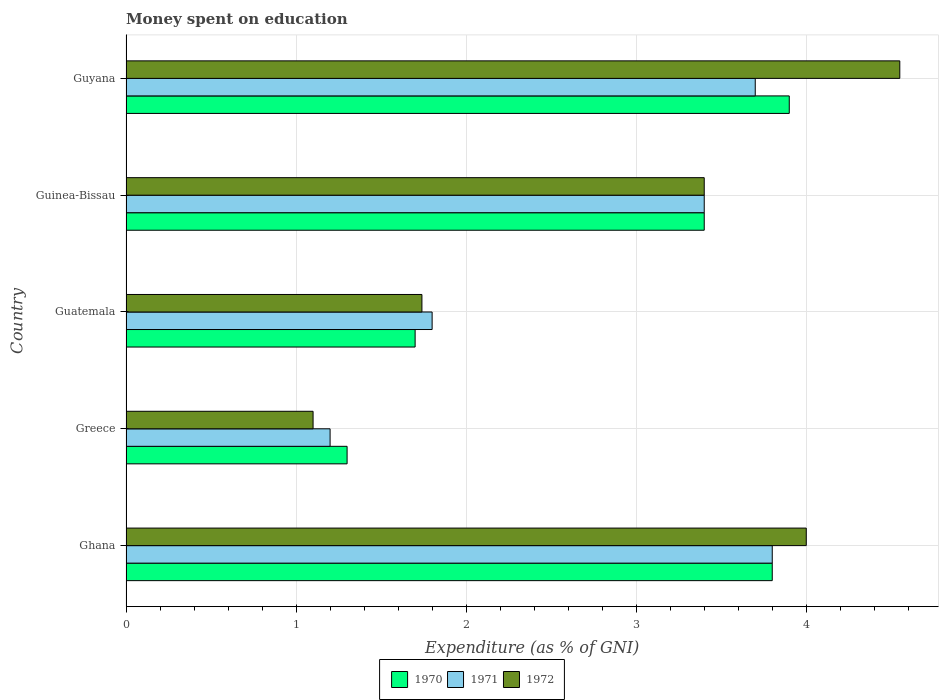How many different coloured bars are there?
Give a very brief answer. 3. How many groups of bars are there?
Offer a terse response. 5. Are the number of bars per tick equal to the number of legend labels?
Keep it short and to the point. Yes. Are the number of bars on each tick of the Y-axis equal?
Give a very brief answer. Yes. How many bars are there on the 1st tick from the bottom?
Make the answer very short. 3. What is the label of the 3rd group of bars from the top?
Give a very brief answer. Guatemala. In how many cases, is the number of bars for a given country not equal to the number of legend labels?
Offer a very short reply. 0. What is the amount of money spent on education in 1972 in Guatemala?
Ensure brevity in your answer.  1.74. Across all countries, what is the maximum amount of money spent on education in 1972?
Keep it short and to the point. 4.55. Across all countries, what is the minimum amount of money spent on education in 1970?
Ensure brevity in your answer.  1.3. In which country was the amount of money spent on education in 1970 maximum?
Ensure brevity in your answer.  Guyana. In which country was the amount of money spent on education in 1971 minimum?
Provide a short and direct response. Greece. What is the total amount of money spent on education in 1971 in the graph?
Provide a short and direct response. 13.9. What is the difference between the amount of money spent on education in 1971 in Greece and that in Guatemala?
Your answer should be very brief. -0.6. What is the difference between the amount of money spent on education in 1970 in Greece and the amount of money spent on education in 1971 in Guinea-Bissau?
Your answer should be compact. -2.1. What is the average amount of money spent on education in 1970 per country?
Your answer should be very brief. 2.82. What is the difference between the amount of money spent on education in 1972 and amount of money spent on education in 1971 in Guyana?
Keep it short and to the point. 0.85. In how many countries, is the amount of money spent on education in 1971 greater than 0.6000000000000001 %?
Make the answer very short. 5. What is the ratio of the amount of money spent on education in 1971 in Greece to that in Guatemala?
Keep it short and to the point. 0.67. Is the difference between the amount of money spent on education in 1972 in Ghana and Guinea-Bissau greater than the difference between the amount of money spent on education in 1971 in Ghana and Guinea-Bissau?
Ensure brevity in your answer.  Yes. What is the difference between the highest and the second highest amount of money spent on education in 1971?
Offer a terse response. 0.1. What is the difference between the highest and the lowest amount of money spent on education in 1970?
Your answer should be compact. 2.6. In how many countries, is the amount of money spent on education in 1971 greater than the average amount of money spent on education in 1971 taken over all countries?
Provide a succinct answer. 3. How many bars are there?
Your response must be concise. 15. Are all the bars in the graph horizontal?
Your answer should be very brief. Yes. Are the values on the major ticks of X-axis written in scientific E-notation?
Ensure brevity in your answer.  No. Does the graph contain any zero values?
Make the answer very short. No. Where does the legend appear in the graph?
Provide a succinct answer. Bottom center. How many legend labels are there?
Provide a short and direct response. 3. How are the legend labels stacked?
Your answer should be very brief. Horizontal. What is the title of the graph?
Your answer should be very brief. Money spent on education. What is the label or title of the X-axis?
Provide a short and direct response. Expenditure (as % of GNI). What is the label or title of the Y-axis?
Offer a terse response. Country. What is the Expenditure (as % of GNI) in 1971 in Ghana?
Keep it short and to the point. 3.8. What is the Expenditure (as % of GNI) of 1972 in Ghana?
Your answer should be compact. 4. What is the Expenditure (as % of GNI) of 1971 in Greece?
Ensure brevity in your answer.  1.2. What is the Expenditure (as % of GNI) of 1972 in Greece?
Provide a succinct answer. 1.1. What is the Expenditure (as % of GNI) in 1971 in Guatemala?
Provide a short and direct response. 1.8. What is the Expenditure (as % of GNI) in 1972 in Guatemala?
Your answer should be compact. 1.74. What is the Expenditure (as % of GNI) of 1970 in Guinea-Bissau?
Your response must be concise. 3.4. What is the Expenditure (as % of GNI) of 1972 in Guinea-Bissau?
Provide a short and direct response. 3.4. What is the Expenditure (as % of GNI) of 1970 in Guyana?
Offer a terse response. 3.9. What is the Expenditure (as % of GNI) in 1971 in Guyana?
Ensure brevity in your answer.  3.7. What is the Expenditure (as % of GNI) in 1972 in Guyana?
Give a very brief answer. 4.55. Across all countries, what is the maximum Expenditure (as % of GNI) in 1970?
Provide a succinct answer. 3.9. Across all countries, what is the maximum Expenditure (as % of GNI) of 1971?
Offer a very short reply. 3.8. Across all countries, what is the maximum Expenditure (as % of GNI) of 1972?
Offer a very short reply. 4.55. Across all countries, what is the minimum Expenditure (as % of GNI) in 1970?
Provide a succinct answer. 1.3. Across all countries, what is the minimum Expenditure (as % of GNI) in 1972?
Your answer should be very brief. 1.1. What is the total Expenditure (as % of GNI) of 1970 in the graph?
Provide a succinct answer. 14.1. What is the total Expenditure (as % of GNI) in 1971 in the graph?
Keep it short and to the point. 13.9. What is the total Expenditure (as % of GNI) of 1972 in the graph?
Provide a short and direct response. 14.79. What is the difference between the Expenditure (as % of GNI) in 1970 in Ghana and that in Greece?
Offer a terse response. 2.5. What is the difference between the Expenditure (as % of GNI) of 1972 in Ghana and that in Guatemala?
Your answer should be compact. 2.26. What is the difference between the Expenditure (as % of GNI) in 1970 in Ghana and that in Guinea-Bissau?
Offer a very short reply. 0.4. What is the difference between the Expenditure (as % of GNI) of 1972 in Ghana and that in Guinea-Bissau?
Offer a very short reply. 0.6. What is the difference between the Expenditure (as % of GNI) in 1972 in Ghana and that in Guyana?
Provide a succinct answer. -0.55. What is the difference between the Expenditure (as % of GNI) in 1972 in Greece and that in Guatemala?
Provide a succinct answer. -0.64. What is the difference between the Expenditure (as % of GNI) of 1972 in Greece and that in Guinea-Bissau?
Your answer should be compact. -2.3. What is the difference between the Expenditure (as % of GNI) of 1971 in Greece and that in Guyana?
Give a very brief answer. -2.5. What is the difference between the Expenditure (as % of GNI) of 1972 in Greece and that in Guyana?
Provide a short and direct response. -3.45. What is the difference between the Expenditure (as % of GNI) of 1971 in Guatemala and that in Guinea-Bissau?
Offer a very short reply. -1.6. What is the difference between the Expenditure (as % of GNI) in 1972 in Guatemala and that in Guinea-Bissau?
Your response must be concise. -1.66. What is the difference between the Expenditure (as % of GNI) in 1970 in Guatemala and that in Guyana?
Provide a short and direct response. -2.2. What is the difference between the Expenditure (as % of GNI) of 1972 in Guatemala and that in Guyana?
Give a very brief answer. -2.81. What is the difference between the Expenditure (as % of GNI) of 1970 in Guinea-Bissau and that in Guyana?
Make the answer very short. -0.5. What is the difference between the Expenditure (as % of GNI) in 1971 in Guinea-Bissau and that in Guyana?
Your answer should be compact. -0.3. What is the difference between the Expenditure (as % of GNI) in 1972 in Guinea-Bissau and that in Guyana?
Make the answer very short. -1.15. What is the difference between the Expenditure (as % of GNI) of 1970 in Ghana and the Expenditure (as % of GNI) of 1971 in Guatemala?
Your response must be concise. 2. What is the difference between the Expenditure (as % of GNI) of 1970 in Ghana and the Expenditure (as % of GNI) of 1972 in Guatemala?
Offer a terse response. 2.06. What is the difference between the Expenditure (as % of GNI) in 1971 in Ghana and the Expenditure (as % of GNI) in 1972 in Guatemala?
Your answer should be very brief. 2.06. What is the difference between the Expenditure (as % of GNI) in 1970 in Ghana and the Expenditure (as % of GNI) in 1971 in Guinea-Bissau?
Your response must be concise. 0.4. What is the difference between the Expenditure (as % of GNI) of 1970 in Ghana and the Expenditure (as % of GNI) of 1972 in Guinea-Bissau?
Keep it short and to the point. 0.4. What is the difference between the Expenditure (as % of GNI) in 1970 in Ghana and the Expenditure (as % of GNI) in 1972 in Guyana?
Your answer should be compact. -0.75. What is the difference between the Expenditure (as % of GNI) in 1971 in Ghana and the Expenditure (as % of GNI) in 1972 in Guyana?
Make the answer very short. -0.75. What is the difference between the Expenditure (as % of GNI) of 1970 in Greece and the Expenditure (as % of GNI) of 1972 in Guatemala?
Your answer should be compact. -0.44. What is the difference between the Expenditure (as % of GNI) in 1971 in Greece and the Expenditure (as % of GNI) in 1972 in Guatemala?
Make the answer very short. -0.54. What is the difference between the Expenditure (as % of GNI) in 1970 in Greece and the Expenditure (as % of GNI) in 1972 in Guinea-Bissau?
Offer a very short reply. -2.1. What is the difference between the Expenditure (as % of GNI) in 1971 in Greece and the Expenditure (as % of GNI) in 1972 in Guinea-Bissau?
Give a very brief answer. -2.2. What is the difference between the Expenditure (as % of GNI) in 1970 in Greece and the Expenditure (as % of GNI) in 1971 in Guyana?
Keep it short and to the point. -2.4. What is the difference between the Expenditure (as % of GNI) in 1970 in Greece and the Expenditure (as % of GNI) in 1972 in Guyana?
Ensure brevity in your answer.  -3.25. What is the difference between the Expenditure (as % of GNI) of 1971 in Greece and the Expenditure (as % of GNI) of 1972 in Guyana?
Make the answer very short. -3.35. What is the difference between the Expenditure (as % of GNI) in 1971 in Guatemala and the Expenditure (as % of GNI) in 1972 in Guinea-Bissau?
Offer a very short reply. -1.6. What is the difference between the Expenditure (as % of GNI) in 1970 in Guatemala and the Expenditure (as % of GNI) in 1972 in Guyana?
Offer a terse response. -2.85. What is the difference between the Expenditure (as % of GNI) of 1971 in Guatemala and the Expenditure (as % of GNI) of 1972 in Guyana?
Your answer should be compact. -2.75. What is the difference between the Expenditure (as % of GNI) of 1970 in Guinea-Bissau and the Expenditure (as % of GNI) of 1971 in Guyana?
Your response must be concise. -0.3. What is the difference between the Expenditure (as % of GNI) of 1970 in Guinea-Bissau and the Expenditure (as % of GNI) of 1972 in Guyana?
Your answer should be very brief. -1.15. What is the difference between the Expenditure (as % of GNI) of 1971 in Guinea-Bissau and the Expenditure (as % of GNI) of 1972 in Guyana?
Provide a succinct answer. -1.15. What is the average Expenditure (as % of GNI) of 1970 per country?
Ensure brevity in your answer.  2.82. What is the average Expenditure (as % of GNI) of 1971 per country?
Keep it short and to the point. 2.78. What is the average Expenditure (as % of GNI) of 1972 per country?
Provide a succinct answer. 2.96. What is the difference between the Expenditure (as % of GNI) in 1970 and Expenditure (as % of GNI) in 1971 in Ghana?
Your answer should be compact. 0. What is the difference between the Expenditure (as % of GNI) of 1970 and Expenditure (as % of GNI) of 1972 in Ghana?
Give a very brief answer. -0.2. What is the difference between the Expenditure (as % of GNI) of 1970 and Expenditure (as % of GNI) of 1972 in Guatemala?
Offer a terse response. -0.04. What is the difference between the Expenditure (as % of GNI) of 1971 and Expenditure (as % of GNI) of 1972 in Guatemala?
Ensure brevity in your answer.  0.06. What is the difference between the Expenditure (as % of GNI) of 1971 and Expenditure (as % of GNI) of 1972 in Guinea-Bissau?
Your answer should be compact. 0. What is the difference between the Expenditure (as % of GNI) of 1970 and Expenditure (as % of GNI) of 1972 in Guyana?
Give a very brief answer. -0.65. What is the difference between the Expenditure (as % of GNI) of 1971 and Expenditure (as % of GNI) of 1972 in Guyana?
Offer a terse response. -0.85. What is the ratio of the Expenditure (as % of GNI) in 1970 in Ghana to that in Greece?
Your answer should be compact. 2.92. What is the ratio of the Expenditure (as % of GNI) of 1971 in Ghana to that in Greece?
Keep it short and to the point. 3.17. What is the ratio of the Expenditure (as % of GNI) in 1972 in Ghana to that in Greece?
Offer a very short reply. 3.64. What is the ratio of the Expenditure (as % of GNI) in 1970 in Ghana to that in Guatemala?
Your answer should be compact. 2.24. What is the ratio of the Expenditure (as % of GNI) of 1971 in Ghana to that in Guatemala?
Your response must be concise. 2.11. What is the ratio of the Expenditure (as % of GNI) in 1972 in Ghana to that in Guatemala?
Make the answer very short. 2.3. What is the ratio of the Expenditure (as % of GNI) in 1970 in Ghana to that in Guinea-Bissau?
Make the answer very short. 1.12. What is the ratio of the Expenditure (as % of GNI) of 1971 in Ghana to that in Guinea-Bissau?
Offer a very short reply. 1.12. What is the ratio of the Expenditure (as % of GNI) of 1972 in Ghana to that in Guinea-Bissau?
Your response must be concise. 1.18. What is the ratio of the Expenditure (as % of GNI) of 1970 in Ghana to that in Guyana?
Provide a succinct answer. 0.97. What is the ratio of the Expenditure (as % of GNI) in 1972 in Ghana to that in Guyana?
Offer a very short reply. 0.88. What is the ratio of the Expenditure (as % of GNI) of 1970 in Greece to that in Guatemala?
Ensure brevity in your answer.  0.76. What is the ratio of the Expenditure (as % of GNI) in 1971 in Greece to that in Guatemala?
Your answer should be compact. 0.67. What is the ratio of the Expenditure (as % of GNI) of 1972 in Greece to that in Guatemala?
Offer a terse response. 0.63. What is the ratio of the Expenditure (as % of GNI) of 1970 in Greece to that in Guinea-Bissau?
Keep it short and to the point. 0.38. What is the ratio of the Expenditure (as % of GNI) in 1971 in Greece to that in Guinea-Bissau?
Provide a succinct answer. 0.35. What is the ratio of the Expenditure (as % of GNI) in 1972 in Greece to that in Guinea-Bissau?
Provide a succinct answer. 0.32. What is the ratio of the Expenditure (as % of GNI) of 1970 in Greece to that in Guyana?
Give a very brief answer. 0.33. What is the ratio of the Expenditure (as % of GNI) in 1971 in Greece to that in Guyana?
Your answer should be very brief. 0.32. What is the ratio of the Expenditure (as % of GNI) in 1972 in Greece to that in Guyana?
Give a very brief answer. 0.24. What is the ratio of the Expenditure (as % of GNI) in 1970 in Guatemala to that in Guinea-Bissau?
Provide a short and direct response. 0.5. What is the ratio of the Expenditure (as % of GNI) in 1971 in Guatemala to that in Guinea-Bissau?
Provide a short and direct response. 0.53. What is the ratio of the Expenditure (as % of GNI) in 1972 in Guatemala to that in Guinea-Bissau?
Provide a short and direct response. 0.51. What is the ratio of the Expenditure (as % of GNI) of 1970 in Guatemala to that in Guyana?
Ensure brevity in your answer.  0.44. What is the ratio of the Expenditure (as % of GNI) in 1971 in Guatemala to that in Guyana?
Give a very brief answer. 0.49. What is the ratio of the Expenditure (as % of GNI) of 1972 in Guatemala to that in Guyana?
Offer a very short reply. 0.38. What is the ratio of the Expenditure (as % of GNI) of 1970 in Guinea-Bissau to that in Guyana?
Offer a very short reply. 0.87. What is the ratio of the Expenditure (as % of GNI) of 1971 in Guinea-Bissau to that in Guyana?
Ensure brevity in your answer.  0.92. What is the ratio of the Expenditure (as % of GNI) in 1972 in Guinea-Bissau to that in Guyana?
Make the answer very short. 0.75. What is the difference between the highest and the second highest Expenditure (as % of GNI) of 1970?
Provide a short and direct response. 0.1. What is the difference between the highest and the second highest Expenditure (as % of GNI) in 1972?
Ensure brevity in your answer.  0.55. What is the difference between the highest and the lowest Expenditure (as % of GNI) in 1970?
Offer a very short reply. 2.6. What is the difference between the highest and the lowest Expenditure (as % of GNI) in 1971?
Offer a terse response. 2.6. What is the difference between the highest and the lowest Expenditure (as % of GNI) of 1972?
Your response must be concise. 3.45. 